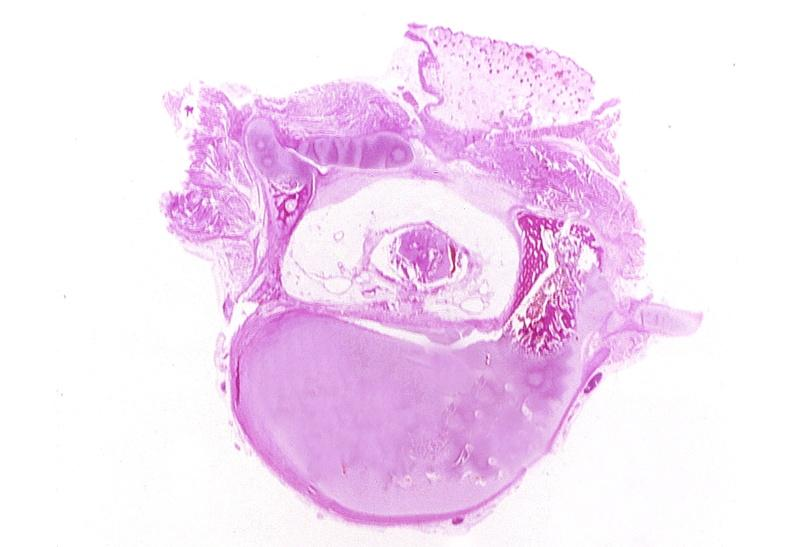where is this?
Answer the question using a single word or phrase. Nervous 